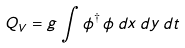<formula> <loc_0><loc_0><loc_500><loc_500>Q _ { V } = g \int \phi ^ { \dagger } \, \phi \, d x \, d y \, d t</formula> 